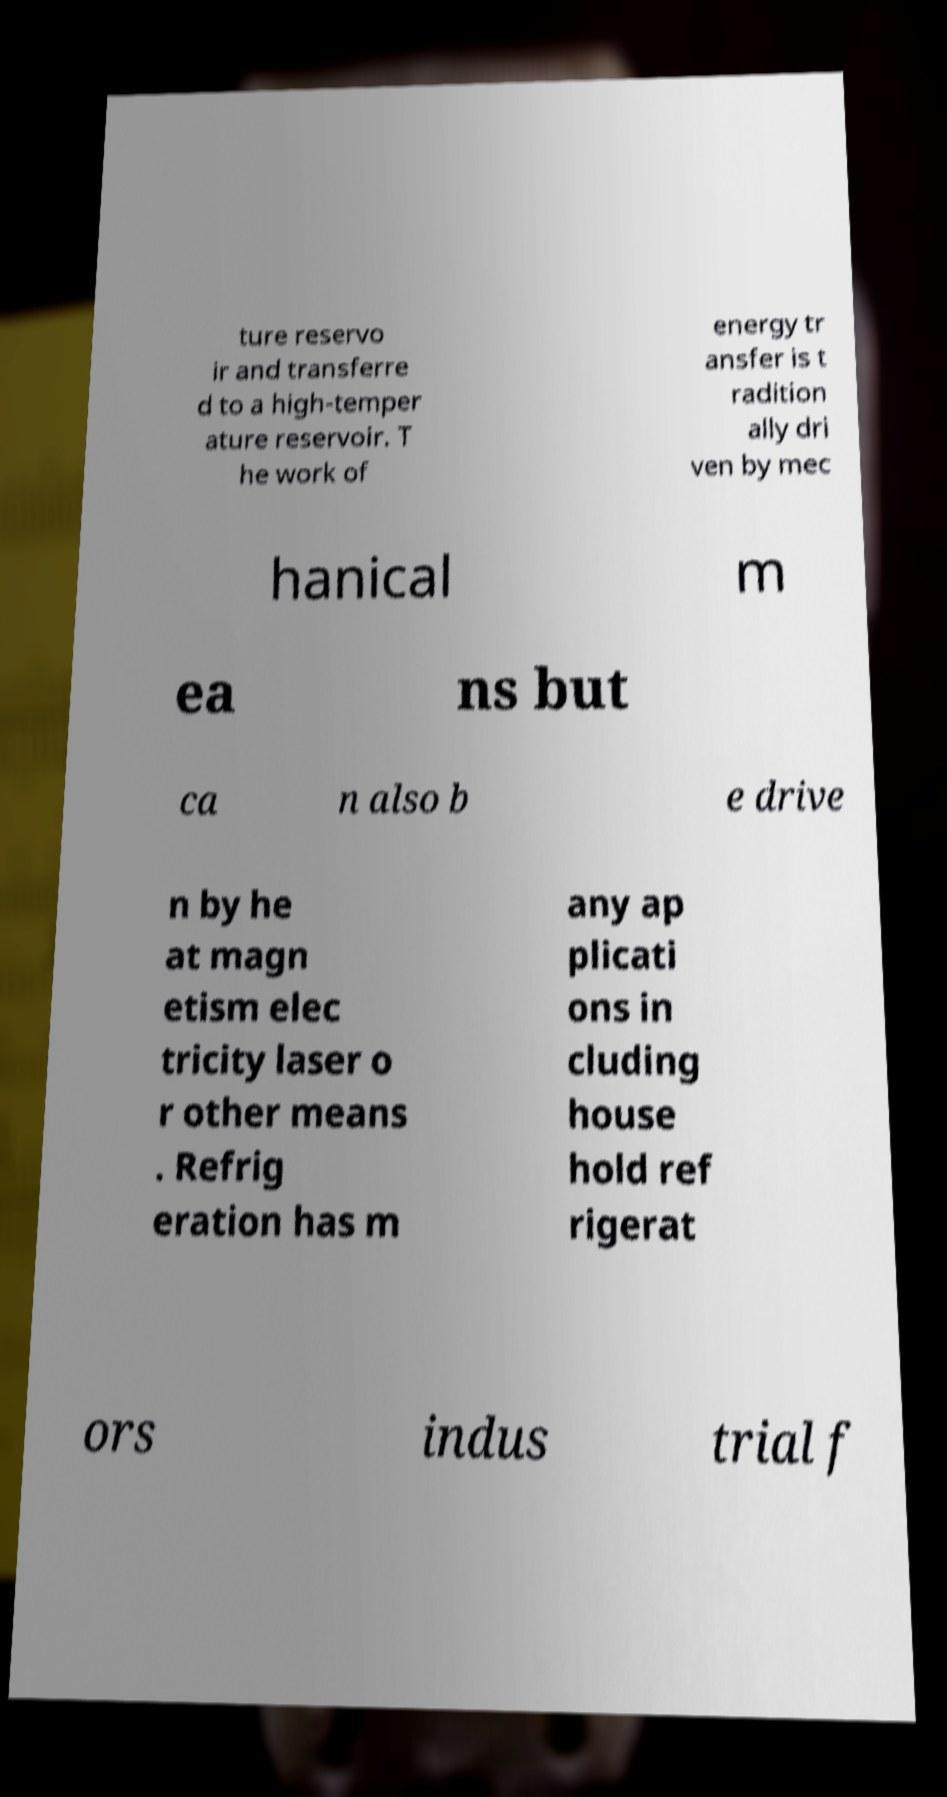I need the written content from this picture converted into text. Can you do that? ture reservo ir and transferre d to a high-temper ature reservoir. T he work of energy tr ansfer is t radition ally dri ven by mec hanical m ea ns but ca n also b e drive n by he at magn etism elec tricity laser o r other means . Refrig eration has m any ap plicati ons in cluding house hold ref rigerat ors indus trial f 